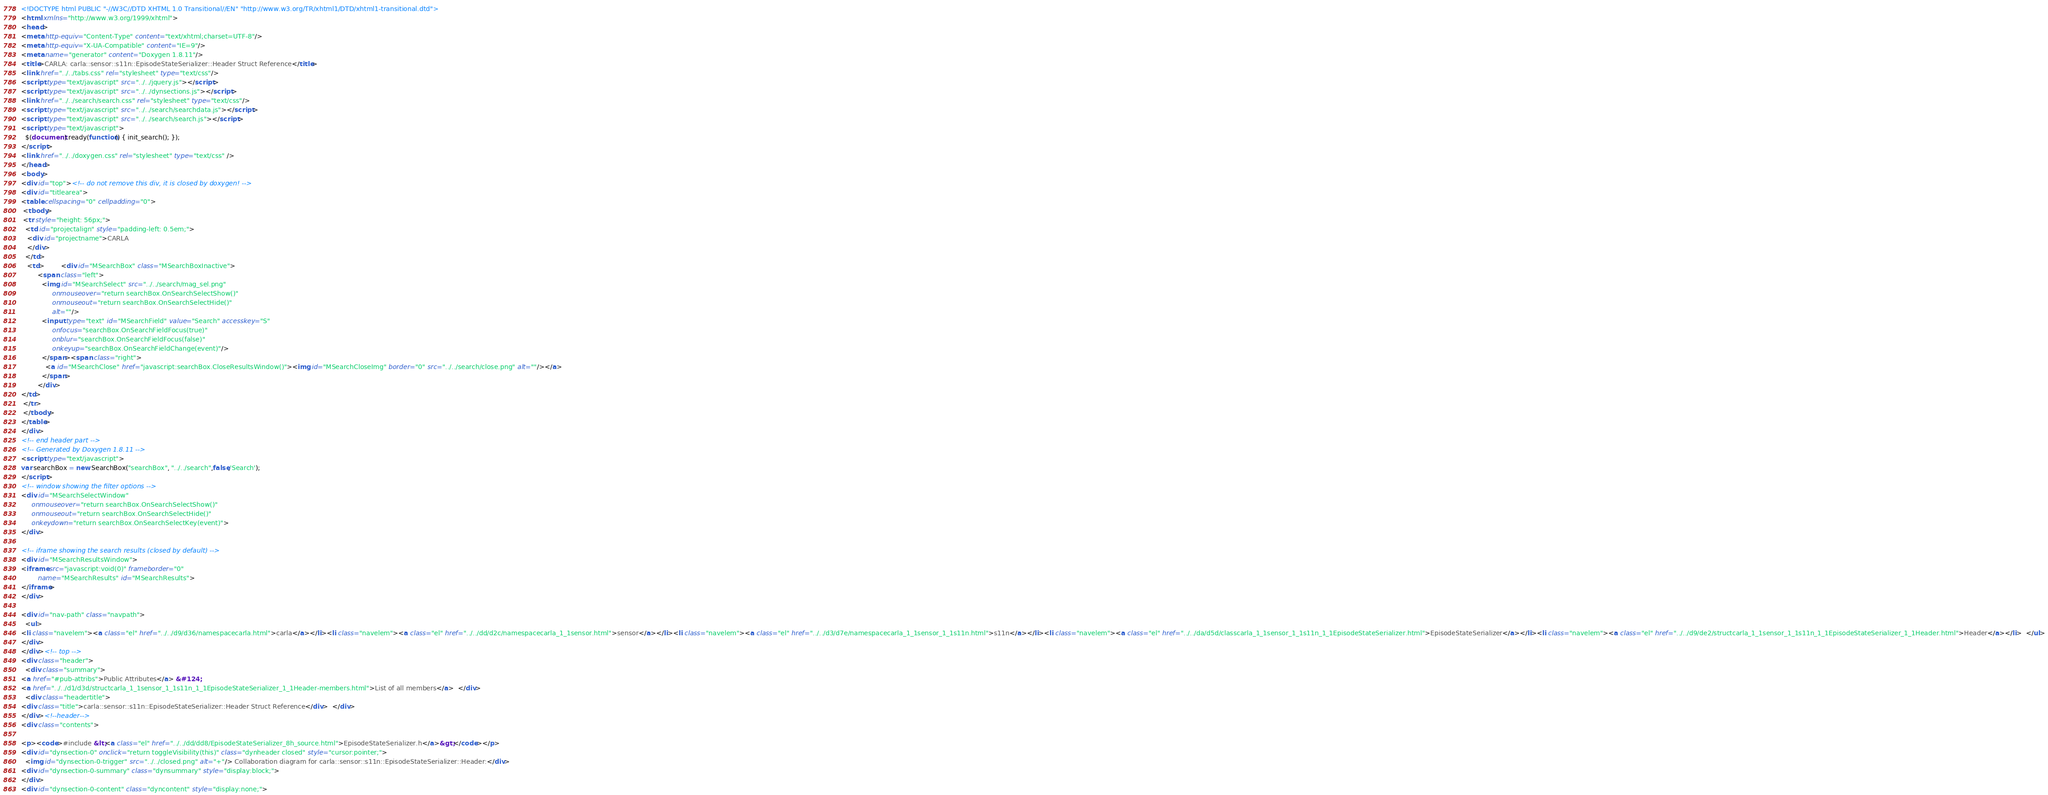Convert code to text. <code><loc_0><loc_0><loc_500><loc_500><_HTML_><!DOCTYPE html PUBLIC "-//W3C//DTD XHTML 1.0 Transitional//EN" "http://www.w3.org/TR/xhtml1/DTD/xhtml1-transitional.dtd">
<html xmlns="http://www.w3.org/1999/xhtml">
<head>
<meta http-equiv="Content-Type" content="text/xhtml;charset=UTF-8"/>
<meta http-equiv="X-UA-Compatible" content="IE=9"/>
<meta name="generator" content="Doxygen 1.8.11"/>
<title>CARLA: carla::sensor::s11n::EpisodeStateSerializer::Header Struct Reference</title>
<link href="../../tabs.css" rel="stylesheet" type="text/css"/>
<script type="text/javascript" src="../../jquery.js"></script>
<script type="text/javascript" src="../../dynsections.js"></script>
<link href="../../search/search.css" rel="stylesheet" type="text/css"/>
<script type="text/javascript" src="../../search/searchdata.js"></script>
<script type="text/javascript" src="../../search/search.js"></script>
<script type="text/javascript">
  $(document).ready(function() { init_search(); });
</script>
<link href="../../doxygen.css" rel="stylesheet" type="text/css" />
</head>
<body>
<div id="top"><!-- do not remove this div, it is closed by doxygen! -->
<div id="titlearea">
<table cellspacing="0" cellpadding="0">
 <tbody>
 <tr style="height: 56px;">
  <td id="projectalign" style="padding-left: 0.5em;">
   <div id="projectname">CARLA
   </div>
  </td>
   <td>        <div id="MSearchBox" class="MSearchBoxInactive">
        <span class="left">
          <img id="MSearchSelect" src="../../search/mag_sel.png"
               onmouseover="return searchBox.OnSearchSelectShow()"
               onmouseout="return searchBox.OnSearchSelectHide()"
               alt=""/>
          <input type="text" id="MSearchField" value="Search" accesskey="S"
               onfocus="searchBox.OnSearchFieldFocus(true)" 
               onblur="searchBox.OnSearchFieldFocus(false)" 
               onkeyup="searchBox.OnSearchFieldChange(event)"/>
          </span><span class="right">
            <a id="MSearchClose" href="javascript:searchBox.CloseResultsWindow()"><img id="MSearchCloseImg" border="0" src="../../search/close.png" alt=""/></a>
          </span>
        </div>
</td>
 </tr>
 </tbody>
</table>
</div>
<!-- end header part -->
<!-- Generated by Doxygen 1.8.11 -->
<script type="text/javascript">
var searchBox = new SearchBox("searchBox", "../../search",false,'Search');
</script>
<!-- window showing the filter options -->
<div id="MSearchSelectWindow"
     onmouseover="return searchBox.OnSearchSelectShow()"
     onmouseout="return searchBox.OnSearchSelectHide()"
     onkeydown="return searchBox.OnSearchSelectKey(event)">
</div>

<!-- iframe showing the search results (closed by default) -->
<div id="MSearchResultsWindow">
<iframe src="javascript:void(0)" frameborder="0" 
        name="MSearchResults" id="MSearchResults">
</iframe>
</div>

<div id="nav-path" class="navpath">
  <ul>
<li class="navelem"><a class="el" href="../../d9/d36/namespacecarla.html">carla</a></li><li class="navelem"><a class="el" href="../../dd/d2c/namespacecarla_1_1sensor.html">sensor</a></li><li class="navelem"><a class="el" href="../../d3/d7e/namespacecarla_1_1sensor_1_1s11n.html">s11n</a></li><li class="navelem"><a class="el" href="../../da/d5d/classcarla_1_1sensor_1_1s11n_1_1EpisodeStateSerializer.html">EpisodeStateSerializer</a></li><li class="navelem"><a class="el" href="../../d9/de2/structcarla_1_1sensor_1_1s11n_1_1EpisodeStateSerializer_1_1Header.html">Header</a></li>  </ul>
</div>
</div><!-- top -->
<div class="header">
  <div class="summary">
<a href="#pub-attribs">Public Attributes</a> &#124;
<a href="../../d1/d3d/structcarla_1_1sensor_1_1s11n_1_1EpisodeStateSerializer_1_1Header-members.html">List of all members</a>  </div>
  <div class="headertitle">
<div class="title">carla::sensor::s11n::EpisodeStateSerializer::Header Struct Reference</div>  </div>
</div><!--header-->
<div class="contents">

<p><code>#include &lt;<a class="el" href="../../dd/dd8/EpisodeStateSerializer_8h_source.html">EpisodeStateSerializer.h</a>&gt;</code></p>
<div id="dynsection-0" onclick="return toggleVisibility(this)" class="dynheader closed" style="cursor:pointer;">
  <img id="dynsection-0-trigger" src="../../closed.png" alt="+"/> Collaboration diagram for carla::sensor::s11n::EpisodeStateSerializer::Header:</div>
<div id="dynsection-0-summary" class="dynsummary" style="display:block;">
</div>
<div id="dynsection-0-content" class="dyncontent" style="display:none;"></code> 